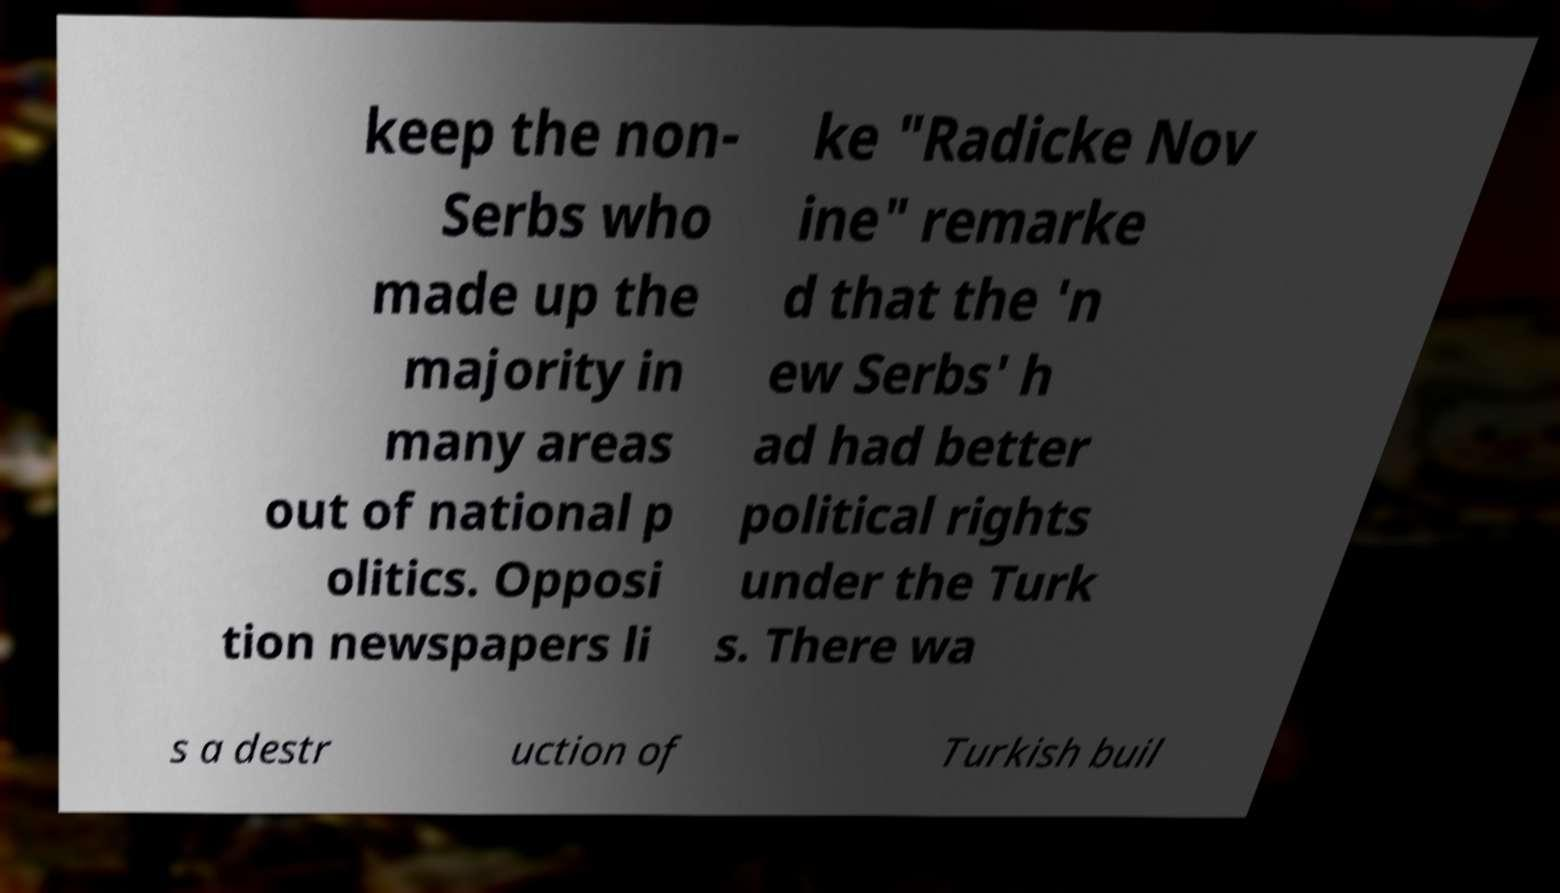Please read and relay the text visible in this image. What does it say? keep the non- Serbs who made up the majority in many areas out of national p olitics. Opposi tion newspapers li ke "Radicke Nov ine" remarke d that the 'n ew Serbs' h ad had better political rights under the Turk s. There wa s a destr uction of Turkish buil 